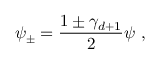Convert formula to latex. <formula><loc_0><loc_0><loc_500><loc_500>\psi _ { \pm } = \frac { 1 \pm \gamma _ { d + 1 } } { 2 } \psi \, ,</formula> 